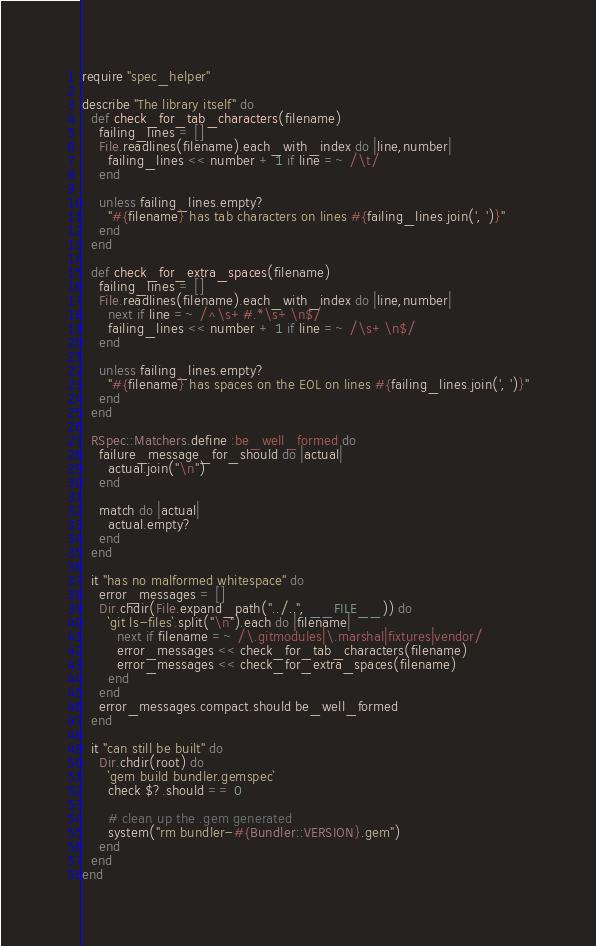<code> <loc_0><loc_0><loc_500><loc_500><_Ruby_>require "spec_helper"

describe "The library itself" do
  def check_for_tab_characters(filename)
    failing_lines = []
    File.readlines(filename).each_with_index do |line,number|
      failing_lines << number + 1 if line =~ /\t/
    end

    unless failing_lines.empty?
      "#{filename} has tab characters on lines #{failing_lines.join(', ')}"
    end
  end

  def check_for_extra_spaces(filename)
    failing_lines = []
    File.readlines(filename).each_with_index do |line,number|
      next if line =~ /^\s+#.*\s+\n$/
      failing_lines << number + 1 if line =~ /\s+\n$/
    end

    unless failing_lines.empty?
      "#{filename} has spaces on the EOL on lines #{failing_lines.join(', ')}"
    end
  end

  RSpec::Matchers.define :be_well_formed do
    failure_message_for_should do |actual|
      actual.join("\n")
    end

    match do |actual|
      actual.empty?
    end
  end

  it "has no malformed whitespace" do
    error_messages = []
    Dir.chdir(File.expand_path("../..", __FILE__)) do
      `git ls-files`.split("\n").each do |filename|
        next if filename =~ /\.gitmodules|\.marshal|fixtures|vendor/
        error_messages << check_for_tab_characters(filename)
        error_messages << check_for_extra_spaces(filename)
      end
    end
    error_messages.compact.should be_well_formed
  end

  it "can still be built" do
    Dir.chdir(root) do
      `gem build bundler.gemspec`
      check $?.should == 0

      # clean up the .gem generated
      system("rm bundler-#{Bundler::VERSION}.gem")
    end
  end
end
</code> 